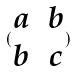<formula> <loc_0><loc_0><loc_500><loc_500>( \begin{matrix} a & b \\ b & c \end{matrix} )</formula> 